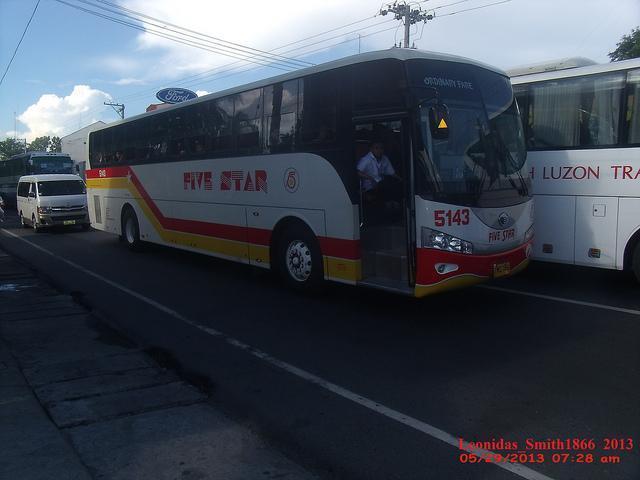How many buses can be seen?
Give a very brief answer. 2. 